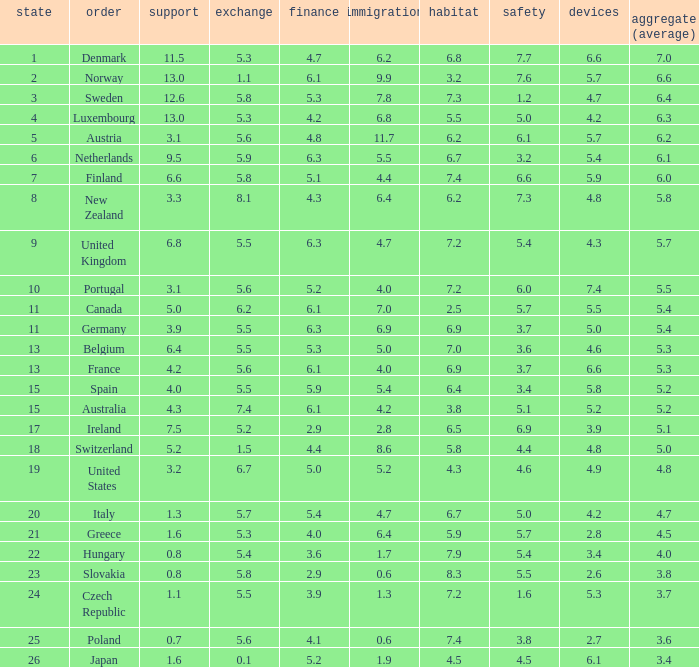What is the environment rating of the country with an overall average rating of 4.7? 6.7. 